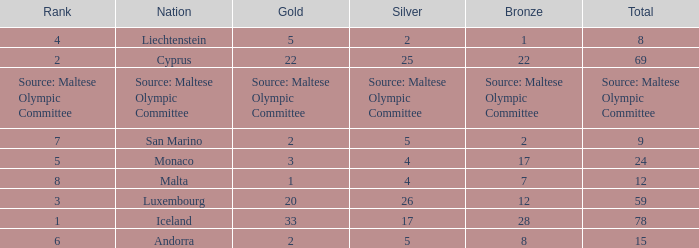What is the total medal count for the nation that has 5 gold? 8.0. 